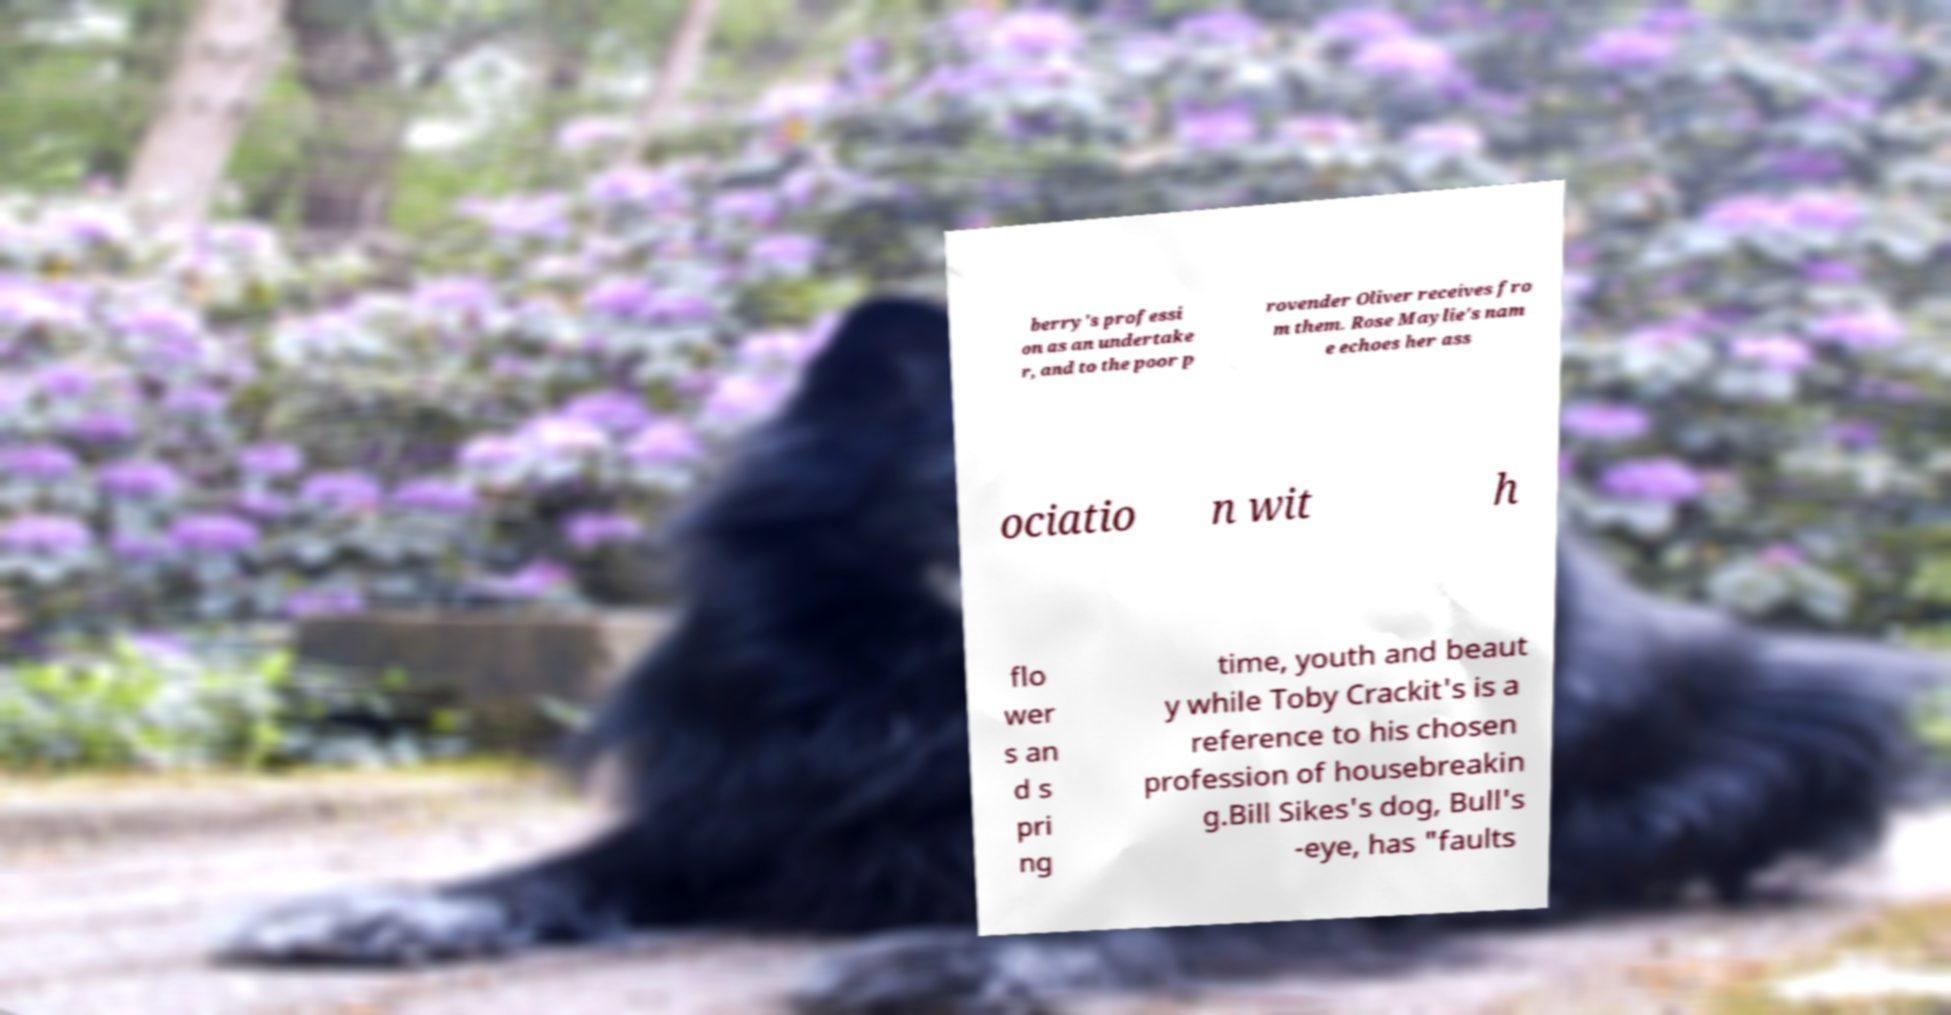Can you read and provide the text displayed in the image?This photo seems to have some interesting text. Can you extract and type it out for me? berry's professi on as an undertake r, and to the poor p rovender Oliver receives fro m them. Rose Maylie's nam e echoes her ass ociatio n wit h flo wer s an d s pri ng time, youth and beaut y while Toby Crackit's is a reference to his chosen profession of housebreakin g.Bill Sikes's dog, Bull's -eye, has "faults 